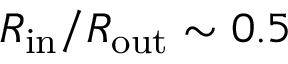Convert formula to latex. <formula><loc_0><loc_0><loc_500><loc_500>R _ { i n } / R _ { o u t } \sim 0 . 5</formula> 